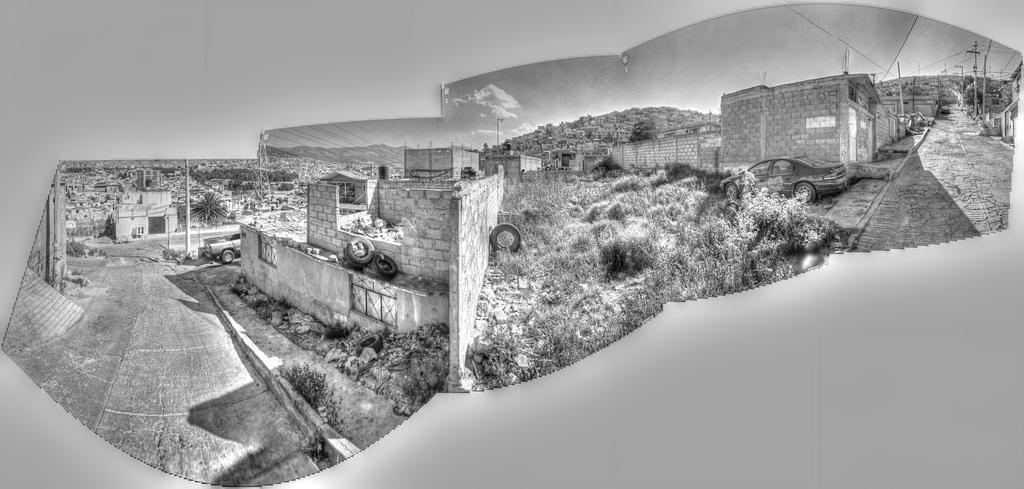Could you give a brief overview of what you see in this image? In this image we can see roads, vehicles, tires, walls and buildings. In the background there is sky. Also there are electric poles with wires. And this is a black and white image. 